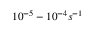Convert formula to latex. <formula><loc_0><loc_0><loc_500><loc_500>1 0 ^ { - 5 } - 1 0 ^ { - 4 } s ^ { - 1 }</formula> 